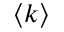<formula> <loc_0><loc_0><loc_500><loc_500>\left < k \right ></formula> 